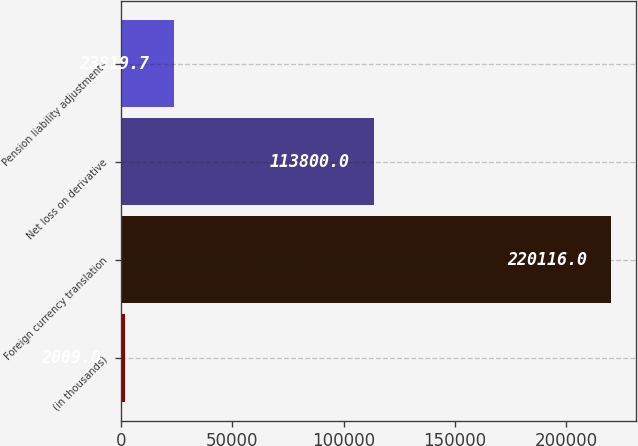Convert chart to OTSL. <chart><loc_0><loc_0><loc_500><loc_500><bar_chart><fcel>(in thousands)<fcel>Foreign currency translation<fcel>Net loss on derivative<fcel>Pension liability adjustments<nl><fcel>2009<fcel>220116<fcel>113800<fcel>23819.7<nl></chart> 